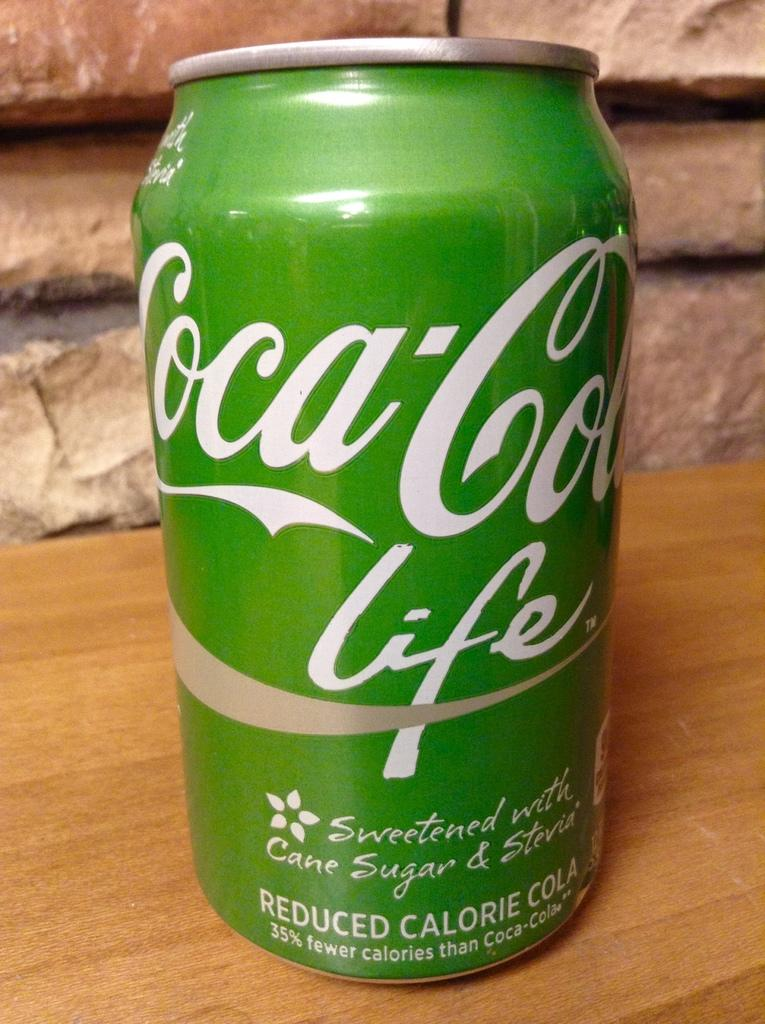<image>
Write a terse but informative summary of the picture. A green can of Coca-Cola has the word life under the name and advertises that it is sweetened with cane sugar and Stevia. 